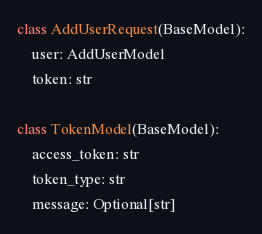Convert code to text. <code><loc_0><loc_0><loc_500><loc_500><_Python_>

class AddUserRequest(BaseModel):
    user: AddUserModel
    token: str

class TokenModel(BaseModel):
    access_token: str
    token_type: str
    message: Optional[str]
</code> 